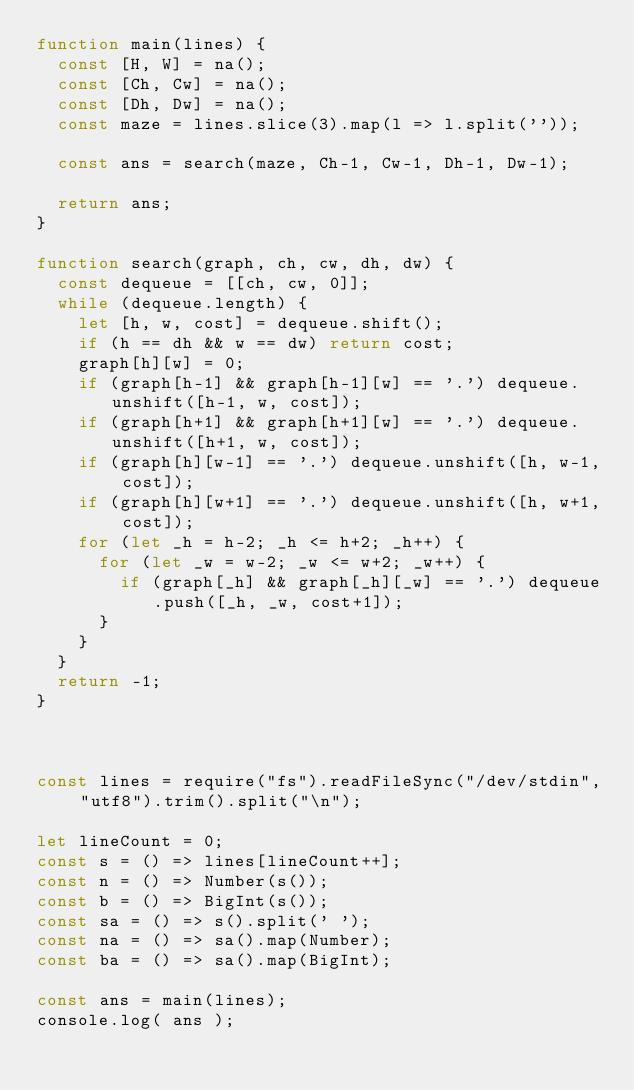<code> <loc_0><loc_0><loc_500><loc_500><_JavaScript_>function main(lines) {
  const [H, W] = na();
  const [Ch, Cw] = na();
  const [Dh, Dw] = na();
  const maze = lines.slice(3).map(l => l.split(''));
  
  const ans = search(maze, Ch-1, Cw-1, Dh-1, Dw-1);
  
  return ans;
}

function search(graph, ch, cw, dh, dw) {
  const dequeue = [[ch, cw, 0]];
  while (dequeue.length) {
    let [h, w, cost] = dequeue.shift();
    if (h == dh && w == dw) return cost;
    graph[h][w] = 0;
    if (graph[h-1] && graph[h-1][w] == '.') dequeue.unshift([h-1, w, cost]);
    if (graph[h+1] && graph[h+1][w] == '.') dequeue.unshift([h+1, w, cost]);
    if (graph[h][w-1] == '.') dequeue.unshift([h, w-1, cost]);
    if (graph[h][w+1] == '.') dequeue.unshift([h, w+1, cost]);
    for (let _h = h-2; _h <= h+2; _h++) {
      for (let _w = w-2; _w <= w+2; _w++) {
        if (graph[_h] && graph[_h][_w] == '.') dequeue.push([_h, _w, cost+1]);
      }
    }
  }
  return -1;
}



const lines = require("fs").readFileSync("/dev/stdin", "utf8").trim().split("\n");

let lineCount = 0;
const s = () => lines[lineCount++];
const n = () => Number(s());
const b = () => BigInt(s());
const sa = () => s().split(' ');
const na = () => sa().map(Number);
const ba = () => sa().map(BigInt);

const ans = main(lines);
console.log( ans );</code> 